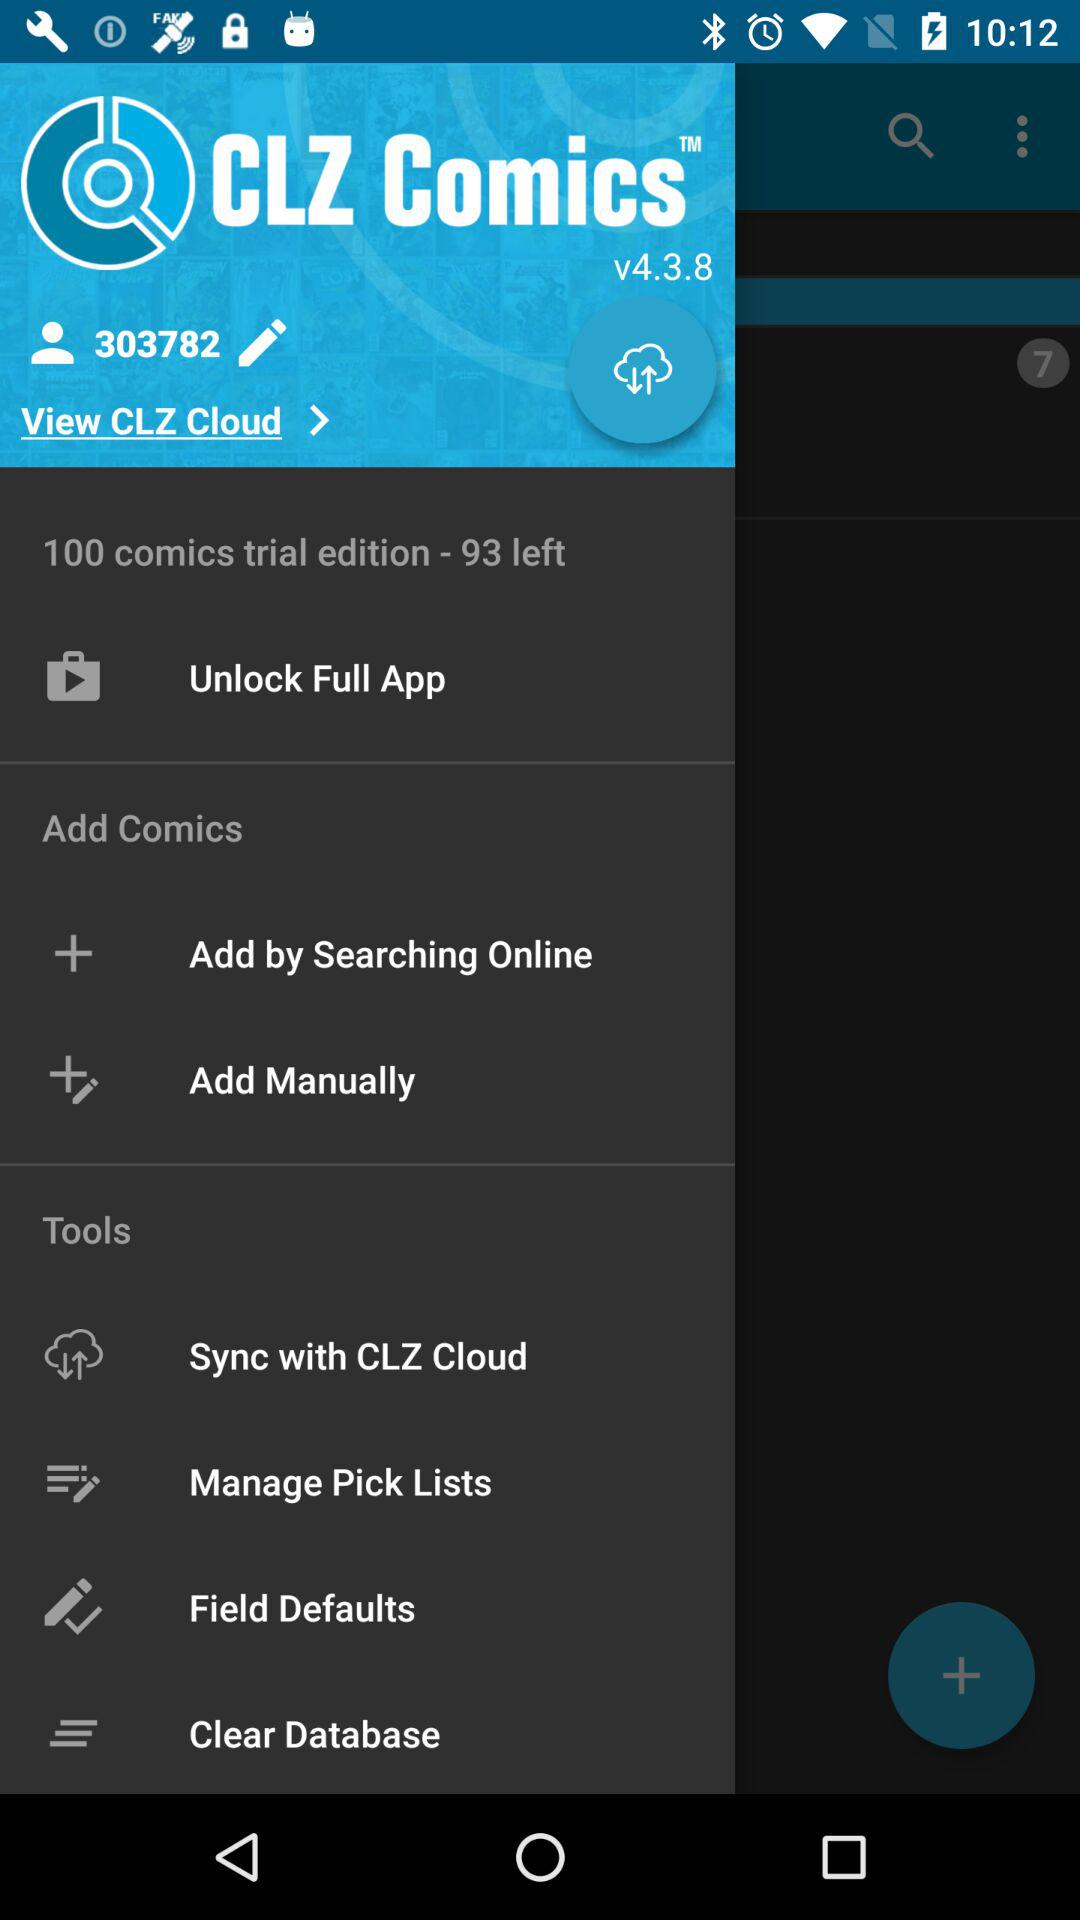How many comics in total are there in the trial edition? There are 100 comics in total in the trial edition. 